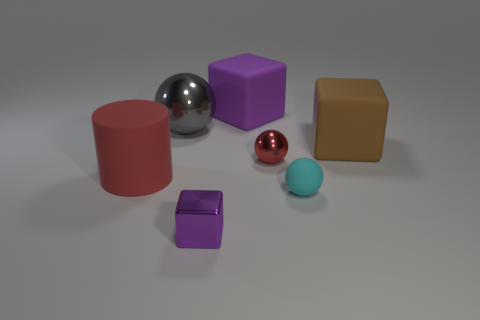Which objects in the image have reflective surfaces? The objects with reflective surfaces are the large silver sphere and the smaller red sphere. Their shiny exteriors clearly stand out and reflect the environment, contrasting with the matte surfaces of the other objects. 